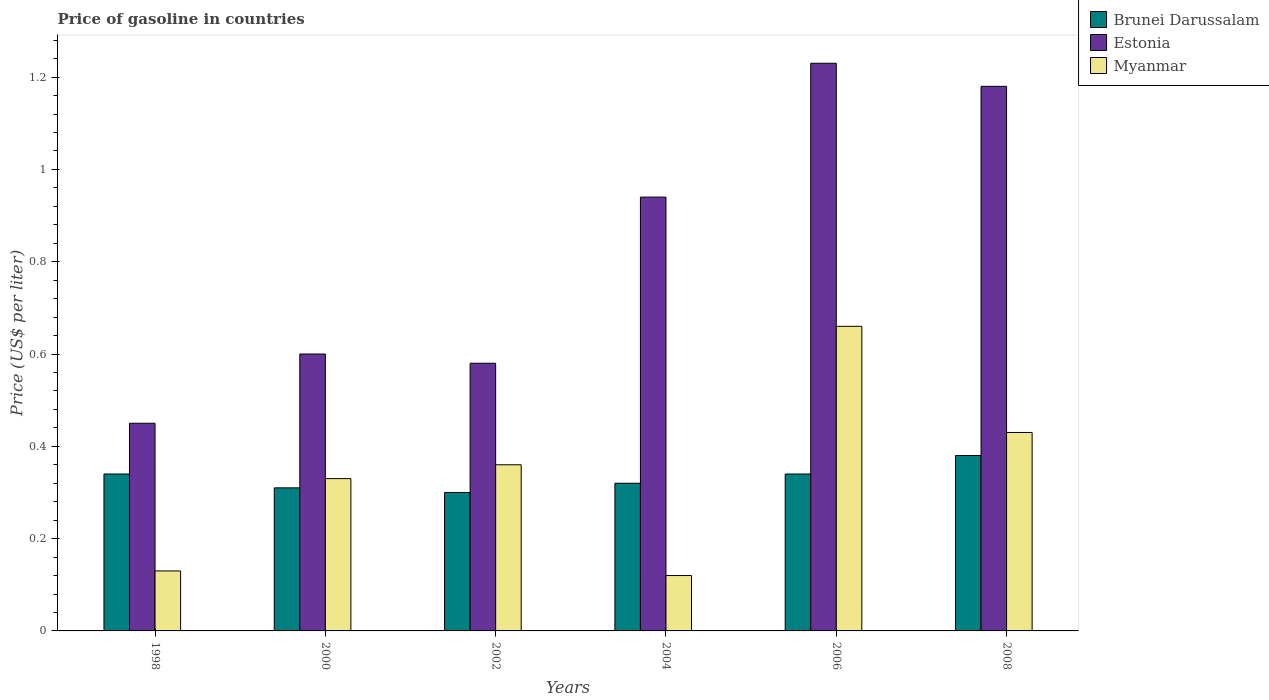How many groups of bars are there?
Offer a very short reply. 6. Are the number of bars on each tick of the X-axis equal?
Your answer should be compact. Yes. How many bars are there on the 6th tick from the left?
Ensure brevity in your answer.  3. In how many cases, is the number of bars for a given year not equal to the number of legend labels?
Make the answer very short. 0. What is the price of gasoline in Brunei Darussalam in 2004?
Offer a very short reply. 0.32. Across all years, what is the maximum price of gasoline in Estonia?
Offer a very short reply. 1.23. Across all years, what is the minimum price of gasoline in Myanmar?
Keep it short and to the point. 0.12. In which year was the price of gasoline in Estonia maximum?
Your answer should be compact. 2006. What is the total price of gasoline in Brunei Darussalam in the graph?
Offer a very short reply. 1.99. What is the difference between the price of gasoline in Myanmar in 2000 and that in 2008?
Offer a terse response. -0.1. What is the difference between the price of gasoline in Myanmar in 2002 and the price of gasoline in Brunei Darussalam in 2004?
Make the answer very short. 0.04. What is the average price of gasoline in Estonia per year?
Your answer should be very brief. 0.83. In the year 1998, what is the difference between the price of gasoline in Myanmar and price of gasoline in Brunei Darussalam?
Your response must be concise. -0.21. In how many years, is the price of gasoline in Myanmar greater than 0.36 US$?
Provide a short and direct response. 2. What is the ratio of the price of gasoline in Brunei Darussalam in 2000 to that in 2006?
Offer a very short reply. 0.91. Is the difference between the price of gasoline in Myanmar in 2000 and 2004 greater than the difference between the price of gasoline in Brunei Darussalam in 2000 and 2004?
Ensure brevity in your answer.  Yes. What is the difference between the highest and the second highest price of gasoline in Brunei Darussalam?
Provide a succinct answer. 0.04. What is the difference between the highest and the lowest price of gasoline in Brunei Darussalam?
Offer a very short reply. 0.08. What does the 2nd bar from the left in 1998 represents?
Provide a succinct answer. Estonia. What does the 3rd bar from the right in 1998 represents?
Provide a short and direct response. Brunei Darussalam. Are all the bars in the graph horizontal?
Keep it short and to the point. No. How many years are there in the graph?
Ensure brevity in your answer.  6. What is the difference between two consecutive major ticks on the Y-axis?
Your response must be concise. 0.2. How are the legend labels stacked?
Offer a terse response. Vertical. What is the title of the graph?
Your response must be concise. Price of gasoline in countries. What is the label or title of the Y-axis?
Your answer should be very brief. Price (US$ per liter). What is the Price (US$ per liter) of Brunei Darussalam in 1998?
Offer a terse response. 0.34. What is the Price (US$ per liter) of Estonia in 1998?
Offer a very short reply. 0.45. What is the Price (US$ per liter) in Myanmar in 1998?
Provide a short and direct response. 0.13. What is the Price (US$ per liter) in Brunei Darussalam in 2000?
Offer a very short reply. 0.31. What is the Price (US$ per liter) of Estonia in 2000?
Provide a succinct answer. 0.6. What is the Price (US$ per liter) in Myanmar in 2000?
Offer a very short reply. 0.33. What is the Price (US$ per liter) in Brunei Darussalam in 2002?
Offer a very short reply. 0.3. What is the Price (US$ per liter) in Estonia in 2002?
Ensure brevity in your answer.  0.58. What is the Price (US$ per liter) of Myanmar in 2002?
Give a very brief answer. 0.36. What is the Price (US$ per liter) of Brunei Darussalam in 2004?
Provide a short and direct response. 0.32. What is the Price (US$ per liter) in Myanmar in 2004?
Offer a very short reply. 0.12. What is the Price (US$ per liter) in Brunei Darussalam in 2006?
Offer a terse response. 0.34. What is the Price (US$ per liter) in Estonia in 2006?
Give a very brief answer. 1.23. What is the Price (US$ per liter) of Myanmar in 2006?
Your response must be concise. 0.66. What is the Price (US$ per liter) of Brunei Darussalam in 2008?
Make the answer very short. 0.38. What is the Price (US$ per liter) of Estonia in 2008?
Your answer should be very brief. 1.18. What is the Price (US$ per liter) of Myanmar in 2008?
Offer a terse response. 0.43. Across all years, what is the maximum Price (US$ per liter) of Brunei Darussalam?
Make the answer very short. 0.38. Across all years, what is the maximum Price (US$ per liter) of Estonia?
Give a very brief answer. 1.23. Across all years, what is the maximum Price (US$ per liter) of Myanmar?
Your response must be concise. 0.66. Across all years, what is the minimum Price (US$ per liter) of Brunei Darussalam?
Offer a very short reply. 0.3. Across all years, what is the minimum Price (US$ per liter) of Estonia?
Offer a terse response. 0.45. Across all years, what is the minimum Price (US$ per liter) of Myanmar?
Your answer should be compact. 0.12. What is the total Price (US$ per liter) of Brunei Darussalam in the graph?
Your answer should be compact. 1.99. What is the total Price (US$ per liter) of Estonia in the graph?
Make the answer very short. 4.98. What is the total Price (US$ per liter) in Myanmar in the graph?
Provide a succinct answer. 2.03. What is the difference between the Price (US$ per liter) in Brunei Darussalam in 1998 and that in 2002?
Your response must be concise. 0.04. What is the difference between the Price (US$ per liter) of Estonia in 1998 and that in 2002?
Provide a succinct answer. -0.13. What is the difference between the Price (US$ per liter) of Myanmar in 1998 and that in 2002?
Make the answer very short. -0.23. What is the difference between the Price (US$ per liter) in Estonia in 1998 and that in 2004?
Your response must be concise. -0.49. What is the difference between the Price (US$ per liter) of Myanmar in 1998 and that in 2004?
Provide a succinct answer. 0.01. What is the difference between the Price (US$ per liter) in Estonia in 1998 and that in 2006?
Give a very brief answer. -0.78. What is the difference between the Price (US$ per liter) in Myanmar in 1998 and that in 2006?
Offer a very short reply. -0.53. What is the difference between the Price (US$ per liter) of Brunei Darussalam in 1998 and that in 2008?
Ensure brevity in your answer.  -0.04. What is the difference between the Price (US$ per liter) in Estonia in 1998 and that in 2008?
Provide a succinct answer. -0.73. What is the difference between the Price (US$ per liter) in Myanmar in 1998 and that in 2008?
Provide a short and direct response. -0.3. What is the difference between the Price (US$ per liter) in Brunei Darussalam in 2000 and that in 2002?
Give a very brief answer. 0.01. What is the difference between the Price (US$ per liter) in Estonia in 2000 and that in 2002?
Keep it short and to the point. 0.02. What is the difference between the Price (US$ per liter) in Myanmar in 2000 and that in 2002?
Provide a succinct answer. -0.03. What is the difference between the Price (US$ per liter) of Brunei Darussalam in 2000 and that in 2004?
Give a very brief answer. -0.01. What is the difference between the Price (US$ per liter) in Estonia in 2000 and that in 2004?
Keep it short and to the point. -0.34. What is the difference between the Price (US$ per liter) in Myanmar in 2000 and that in 2004?
Provide a short and direct response. 0.21. What is the difference between the Price (US$ per liter) of Brunei Darussalam in 2000 and that in 2006?
Provide a short and direct response. -0.03. What is the difference between the Price (US$ per liter) in Estonia in 2000 and that in 2006?
Offer a very short reply. -0.63. What is the difference between the Price (US$ per liter) of Myanmar in 2000 and that in 2006?
Offer a very short reply. -0.33. What is the difference between the Price (US$ per liter) of Brunei Darussalam in 2000 and that in 2008?
Offer a very short reply. -0.07. What is the difference between the Price (US$ per liter) in Estonia in 2000 and that in 2008?
Provide a short and direct response. -0.58. What is the difference between the Price (US$ per liter) of Brunei Darussalam in 2002 and that in 2004?
Your answer should be very brief. -0.02. What is the difference between the Price (US$ per liter) in Estonia in 2002 and that in 2004?
Your answer should be very brief. -0.36. What is the difference between the Price (US$ per liter) of Myanmar in 2002 and that in 2004?
Keep it short and to the point. 0.24. What is the difference between the Price (US$ per liter) in Brunei Darussalam in 2002 and that in 2006?
Offer a terse response. -0.04. What is the difference between the Price (US$ per liter) of Estonia in 2002 and that in 2006?
Make the answer very short. -0.65. What is the difference between the Price (US$ per liter) in Brunei Darussalam in 2002 and that in 2008?
Your answer should be very brief. -0.08. What is the difference between the Price (US$ per liter) of Myanmar in 2002 and that in 2008?
Offer a terse response. -0.07. What is the difference between the Price (US$ per liter) of Brunei Darussalam in 2004 and that in 2006?
Provide a succinct answer. -0.02. What is the difference between the Price (US$ per liter) of Estonia in 2004 and that in 2006?
Your response must be concise. -0.29. What is the difference between the Price (US$ per liter) of Myanmar in 2004 and that in 2006?
Make the answer very short. -0.54. What is the difference between the Price (US$ per liter) of Brunei Darussalam in 2004 and that in 2008?
Keep it short and to the point. -0.06. What is the difference between the Price (US$ per liter) of Estonia in 2004 and that in 2008?
Offer a very short reply. -0.24. What is the difference between the Price (US$ per liter) of Myanmar in 2004 and that in 2008?
Offer a terse response. -0.31. What is the difference between the Price (US$ per liter) in Brunei Darussalam in 2006 and that in 2008?
Provide a succinct answer. -0.04. What is the difference between the Price (US$ per liter) in Estonia in 2006 and that in 2008?
Your answer should be compact. 0.05. What is the difference between the Price (US$ per liter) in Myanmar in 2006 and that in 2008?
Ensure brevity in your answer.  0.23. What is the difference between the Price (US$ per liter) in Brunei Darussalam in 1998 and the Price (US$ per liter) in Estonia in 2000?
Ensure brevity in your answer.  -0.26. What is the difference between the Price (US$ per liter) of Brunei Darussalam in 1998 and the Price (US$ per liter) of Myanmar in 2000?
Ensure brevity in your answer.  0.01. What is the difference between the Price (US$ per liter) of Estonia in 1998 and the Price (US$ per liter) of Myanmar in 2000?
Provide a succinct answer. 0.12. What is the difference between the Price (US$ per liter) of Brunei Darussalam in 1998 and the Price (US$ per liter) of Estonia in 2002?
Your answer should be very brief. -0.24. What is the difference between the Price (US$ per liter) of Brunei Darussalam in 1998 and the Price (US$ per liter) of Myanmar in 2002?
Keep it short and to the point. -0.02. What is the difference between the Price (US$ per liter) of Estonia in 1998 and the Price (US$ per liter) of Myanmar in 2002?
Provide a short and direct response. 0.09. What is the difference between the Price (US$ per liter) of Brunei Darussalam in 1998 and the Price (US$ per liter) of Estonia in 2004?
Offer a terse response. -0.6. What is the difference between the Price (US$ per liter) in Brunei Darussalam in 1998 and the Price (US$ per liter) in Myanmar in 2004?
Your response must be concise. 0.22. What is the difference between the Price (US$ per liter) in Estonia in 1998 and the Price (US$ per liter) in Myanmar in 2004?
Give a very brief answer. 0.33. What is the difference between the Price (US$ per liter) in Brunei Darussalam in 1998 and the Price (US$ per liter) in Estonia in 2006?
Your answer should be very brief. -0.89. What is the difference between the Price (US$ per liter) of Brunei Darussalam in 1998 and the Price (US$ per liter) of Myanmar in 2006?
Your response must be concise. -0.32. What is the difference between the Price (US$ per liter) in Estonia in 1998 and the Price (US$ per liter) in Myanmar in 2006?
Offer a terse response. -0.21. What is the difference between the Price (US$ per liter) of Brunei Darussalam in 1998 and the Price (US$ per liter) of Estonia in 2008?
Keep it short and to the point. -0.84. What is the difference between the Price (US$ per liter) of Brunei Darussalam in 1998 and the Price (US$ per liter) of Myanmar in 2008?
Provide a succinct answer. -0.09. What is the difference between the Price (US$ per liter) in Brunei Darussalam in 2000 and the Price (US$ per liter) in Estonia in 2002?
Provide a short and direct response. -0.27. What is the difference between the Price (US$ per liter) in Estonia in 2000 and the Price (US$ per liter) in Myanmar in 2002?
Offer a terse response. 0.24. What is the difference between the Price (US$ per liter) of Brunei Darussalam in 2000 and the Price (US$ per liter) of Estonia in 2004?
Give a very brief answer. -0.63. What is the difference between the Price (US$ per liter) of Brunei Darussalam in 2000 and the Price (US$ per liter) of Myanmar in 2004?
Keep it short and to the point. 0.19. What is the difference between the Price (US$ per liter) of Estonia in 2000 and the Price (US$ per liter) of Myanmar in 2004?
Give a very brief answer. 0.48. What is the difference between the Price (US$ per liter) in Brunei Darussalam in 2000 and the Price (US$ per liter) in Estonia in 2006?
Your answer should be very brief. -0.92. What is the difference between the Price (US$ per liter) in Brunei Darussalam in 2000 and the Price (US$ per liter) in Myanmar in 2006?
Your answer should be compact. -0.35. What is the difference between the Price (US$ per liter) in Estonia in 2000 and the Price (US$ per liter) in Myanmar in 2006?
Provide a short and direct response. -0.06. What is the difference between the Price (US$ per liter) in Brunei Darussalam in 2000 and the Price (US$ per liter) in Estonia in 2008?
Keep it short and to the point. -0.87. What is the difference between the Price (US$ per liter) of Brunei Darussalam in 2000 and the Price (US$ per liter) of Myanmar in 2008?
Your answer should be very brief. -0.12. What is the difference between the Price (US$ per liter) in Estonia in 2000 and the Price (US$ per liter) in Myanmar in 2008?
Your answer should be compact. 0.17. What is the difference between the Price (US$ per liter) of Brunei Darussalam in 2002 and the Price (US$ per liter) of Estonia in 2004?
Your answer should be compact. -0.64. What is the difference between the Price (US$ per liter) of Brunei Darussalam in 2002 and the Price (US$ per liter) of Myanmar in 2004?
Ensure brevity in your answer.  0.18. What is the difference between the Price (US$ per liter) of Estonia in 2002 and the Price (US$ per liter) of Myanmar in 2004?
Your response must be concise. 0.46. What is the difference between the Price (US$ per liter) in Brunei Darussalam in 2002 and the Price (US$ per liter) in Estonia in 2006?
Your answer should be compact. -0.93. What is the difference between the Price (US$ per liter) in Brunei Darussalam in 2002 and the Price (US$ per liter) in Myanmar in 2006?
Give a very brief answer. -0.36. What is the difference between the Price (US$ per liter) in Estonia in 2002 and the Price (US$ per liter) in Myanmar in 2006?
Offer a terse response. -0.08. What is the difference between the Price (US$ per liter) in Brunei Darussalam in 2002 and the Price (US$ per liter) in Estonia in 2008?
Your answer should be compact. -0.88. What is the difference between the Price (US$ per liter) in Brunei Darussalam in 2002 and the Price (US$ per liter) in Myanmar in 2008?
Your response must be concise. -0.13. What is the difference between the Price (US$ per liter) of Brunei Darussalam in 2004 and the Price (US$ per liter) of Estonia in 2006?
Offer a very short reply. -0.91. What is the difference between the Price (US$ per liter) of Brunei Darussalam in 2004 and the Price (US$ per liter) of Myanmar in 2006?
Offer a terse response. -0.34. What is the difference between the Price (US$ per liter) in Estonia in 2004 and the Price (US$ per liter) in Myanmar in 2006?
Provide a succinct answer. 0.28. What is the difference between the Price (US$ per liter) in Brunei Darussalam in 2004 and the Price (US$ per liter) in Estonia in 2008?
Your answer should be compact. -0.86. What is the difference between the Price (US$ per liter) in Brunei Darussalam in 2004 and the Price (US$ per liter) in Myanmar in 2008?
Provide a succinct answer. -0.11. What is the difference between the Price (US$ per liter) of Estonia in 2004 and the Price (US$ per liter) of Myanmar in 2008?
Your response must be concise. 0.51. What is the difference between the Price (US$ per liter) in Brunei Darussalam in 2006 and the Price (US$ per liter) in Estonia in 2008?
Make the answer very short. -0.84. What is the difference between the Price (US$ per liter) of Brunei Darussalam in 2006 and the Price (US$ per liter) of Myanmar in 2008?
Keep it short and to the point. -0.09. What is the average Price (US$ per liter) of Brunei Darussalam per year?
Provide a succinct answer. 0.33. What is the average Price (US$ per liter) in Estonia per year?
Offer a very short reply. 0.83. What is the average Price (US$ per liter) of Myanmar per year?
Keep it short and to the point. 0.34. In the year 1998, what is the difference between the Price (US$ per liter) of Brunei Darussalam and Price (US$ per liter) of Estonia?
Provide a succinct answer. -0.11. In the year 1998, what is the difference between the Price (US$ per liter) of Brunei Darussalam and Price (US$ per liter) of Myanmar?
Your answer should be very brief. 0.21. In the year 1998, what is the difference between the Price (US$ per liter) in Estonia and Price (US$ per liter) in Myanmar?
Your answer should be compact. 0.32. In the year 2000, what is the difference between the Price (US$ per liter) in Brunei Darussalam and Price (US$ per liter) in Estonia?
Your answer should be very brief. -0.29. In the year 2000, what is the difference between the Price (US$ per liter) of Brunei Darussalam and Price (US$ per liter) of Myanmar?
Your answer should be very brief. -0.02. In the year 2000, what is the difference between the Price (US$ per liter) in Estonia and Price (US$ per liter) in Myanmar?
Offer a terse response. 0.27. In the year 2002, what is the difference between the Price (US$ per liter) of Brunei Darussalam and Price (US$ per liter) of Estonia?
Your answer should be very brief. -0.28. In the year 2002, what is the difference between the Price (US$ per liter) of Brunei Darussalam and Price (US$ per liter) of Myanmar?
Provide a succinct answer. -0.06. In the year 2002, what is the difference between the Price (US$ per liter) of Estonia and Price (US$ per liter) of Myanmar?
Your answer should be compact. 0.22. In the year 2004, what is the difference between the Price (US$ per liter) of Brunei Darussalam and Price (US$ per liter) of Estonia?
Give a very brief answer. -0.62. In the year 2004, what is the difference between the Price (US$ per liter) of Brunei Darussalam and Price (US$ per liter) of Myanmar?
Keep it short and to the point. 0.2. In the year 2004, what is the difference between the Price (US$ per liter) in Estonia and Price (US$ per liter) in Myanmar?
Your response must be concise. 0.82. In the year 2006, what is the difference between the Price (US$ per liter) in Brunei Darussalam and Price (US$ per liter) in Estonia?
Offer a terse response. -0.89. In the year 2006, what is the difference between the Price (US$ per liter) in Brunei Darussalam and Price (US$ per liter) in Myanmar?
Make the answer very short. -0.32. In the year 2006, what is the difference between the Price (US$ per liter) in Estonia and Price (US$ per liter) in Myanmar?
Make the answer very short. 0.57. In the year 2008, what is the difference between the Price (US$ per liter) in Estonia and Price (US$ per liter) in Myanmar?
Make the answer very short. 0.75. What is the ratio of the Price (US$ per liter) of Brunei Darussalam in 1998 to that in 2000?
Ensure brevity in your answer.  1.1. What is the ratio of the Price (US$ per liter) in Myanmar in 1998 to that in 2000?
Give a very brief answer. 0.39. What is the ratio of the Price (US$ per liter) of Brunei Darussalam in 1998 to that in 2002?
Your answer should be compact. 1.13. What is the ratio of the Price (US$ per liter) in Estonia in 1998 to that in 2002?
Your answer should be very brief. 0.78. What is the ratio of the Price (US$ per liter) in Myanmar in 1998 to that in 2002?
Provide a short and direct response. 0.36. What is the ratio of the Price (US$ per liter) of Estonia in 1998 to that in 2004?
Offer a terse response. 0.48. What is the ratio of the Price (US$ per liter) of Myanmar in 1998 to that in 2004?
Your response must be concise. 1.08. What is the ratio of the Price (US$ per liter) of Estonia in 1998 to that in 2006?
Make the answer very short. 0.37. What is the ratio of the Price (US$ per liter) in Myanmar in 1998 to that in 2006?
Provide a short and direct response. 0.2. What is the ratio of the Price (US$ per liter) of Brunei Darussalam in 1998 to that in 2008?
Provide a short and direct response. 0.89. What is the ratio of the Price (US$ per liter) in Estonia in 1998 to that in 2008?
Your response must be concise. 0.38. What is the ratio of the Price (US$ per liter) in Myanmar in 1998 to that in 2008?
Ensure brevity in your answer.  0.3. What is the ratio of the Price (US$ per liter) in Brunei Darussalam in 2000 to that in 2002?
Ensure brevity in your answer.  1.03. What is the ratio of the Price (US$ per liter) of Estonia in 2000 to that in 2002?
Ensure brevity in your answer.  1.03. What is the ratio of the Price (US$ per liter) in Brunei Darussalam in 2000 to that in 2004?
Your answer should be very brief. 0.97. What is the ratio of the Price (US$ per liter) of Estonia in 2000 to that in 2004?
Your answer should be compact. 0.64. What is the ratio of the Price (US$ per liter) of Myanmar in 2000 to that in 2004?
Ensure brevity in your answer.  2.75. What is the ratio of the Price (US$ per liter) in Brunei Darussalam in 2000 to that in 2006?
Your answer should be compact. 0.91. What is the ratio of the Price (US$ per liter) of Estonia in 2000 to that in 2006?
Offer a terse response. 0.49. What is the ratio of the Price (US$ per liter) in Myanmar in 2000 to that in 2006?
Ensure brevity in your answer.  0.5. What is the ratio of the Price (US$ per liter) in Brunei Darussalam in 2000 to that in 2008?
Offer a terse response. 0.82. What is the ratio of the Price (US$ per liter) in Estonia in 2000 to that in 2008?
Your answer should be compact. 0.51. What is the ratio of the Price (US$ per liter) of Myanmar in 2000 to that in 2008?
Your response must be concise. 0.77. What is the ratio of the Price (US$ per liter) of Estonia in 2002 to that in 2004?
Keep it short and to the point. 0.62. What is the ratio of the Price (US$ per liter) of Myanmar in 2002 to that in 2004?
Ensure brevity in your answer.  3. What is the ratio of the Price (US$ per liter) in Brunei Darussalam in 2002 to that in 2006?
Make the answer very short. 0.88. What is the ratio of the Price (US$ per liter) in Estonia in 2002 to that in 2006?
Make the answer very short. 0.47. What is the ratio of the Price (US$ per liter) in Myanmar in 2002 to that in 2006?
Keep it short and to the point. 0.55. What is the ratio of the Price (US$ per liter) of Brunei Darussalam in 2002 to that in 2008?
Your answer should be compact. 0.79. What is the ratio of the Price (US$ per liter) in Estonia in 2002 to that in 2008?
Your response must be concise. 0.49. What is the ratio of the Price (US$ per liter) of Myanmar in 2002 to that in 2008?
Keep it short and to the point. 0.84. What is the ratio of the Price (US$ per liter) in Estonia in 2004 to that in 2006?
Provide a succinct answer. 0.76. What is the ratio of the Price (US$ per liter) of Myanmar in 2004 to that in 2006?
Provide a short and direct response. 0.18. What is the ratio of the Price (US$ per liter) of Brunei Darussalam in 2004 to that in 2008?
Provide a succinct answer. 0.84. What is the ratio of the Price (US$ per liter) in Estonia in 2004 to that in 2008?
Provide a succinct answer. 0.8. What is the ratio of the Price (US$ per liter) in Myanmar in 2004 to that in 2008?
Provide a succinct answer. 0.28. What is the ratio of the Price (US$ per liter) of Brunei Darussalam in 2006 to that in 2008?
Provide a succinct answer. 0.89. What is the ratio of the Price (US$ per liter) in Estonia in 2006 to that in 2008?
Offer a very short reply. 1.04. What is the ratio of the Price (US$ per liter) of Myanmar in 2006 to that in 2008?
Provide a short and direct response. 1.53. What is the difference between the highest and the second highest Price (US$ per liter) in Myanmar?
Keep it short and to the point. 0.23. What is the difference between the highest and the lowest Price (US$ per liter) of Estonia?
Give a very brief answer. 0.78. What is the difference between the highest and the lowest Price (US$ per liter) in Myanmar?
Ensure brevity in your answer.  0.54. 